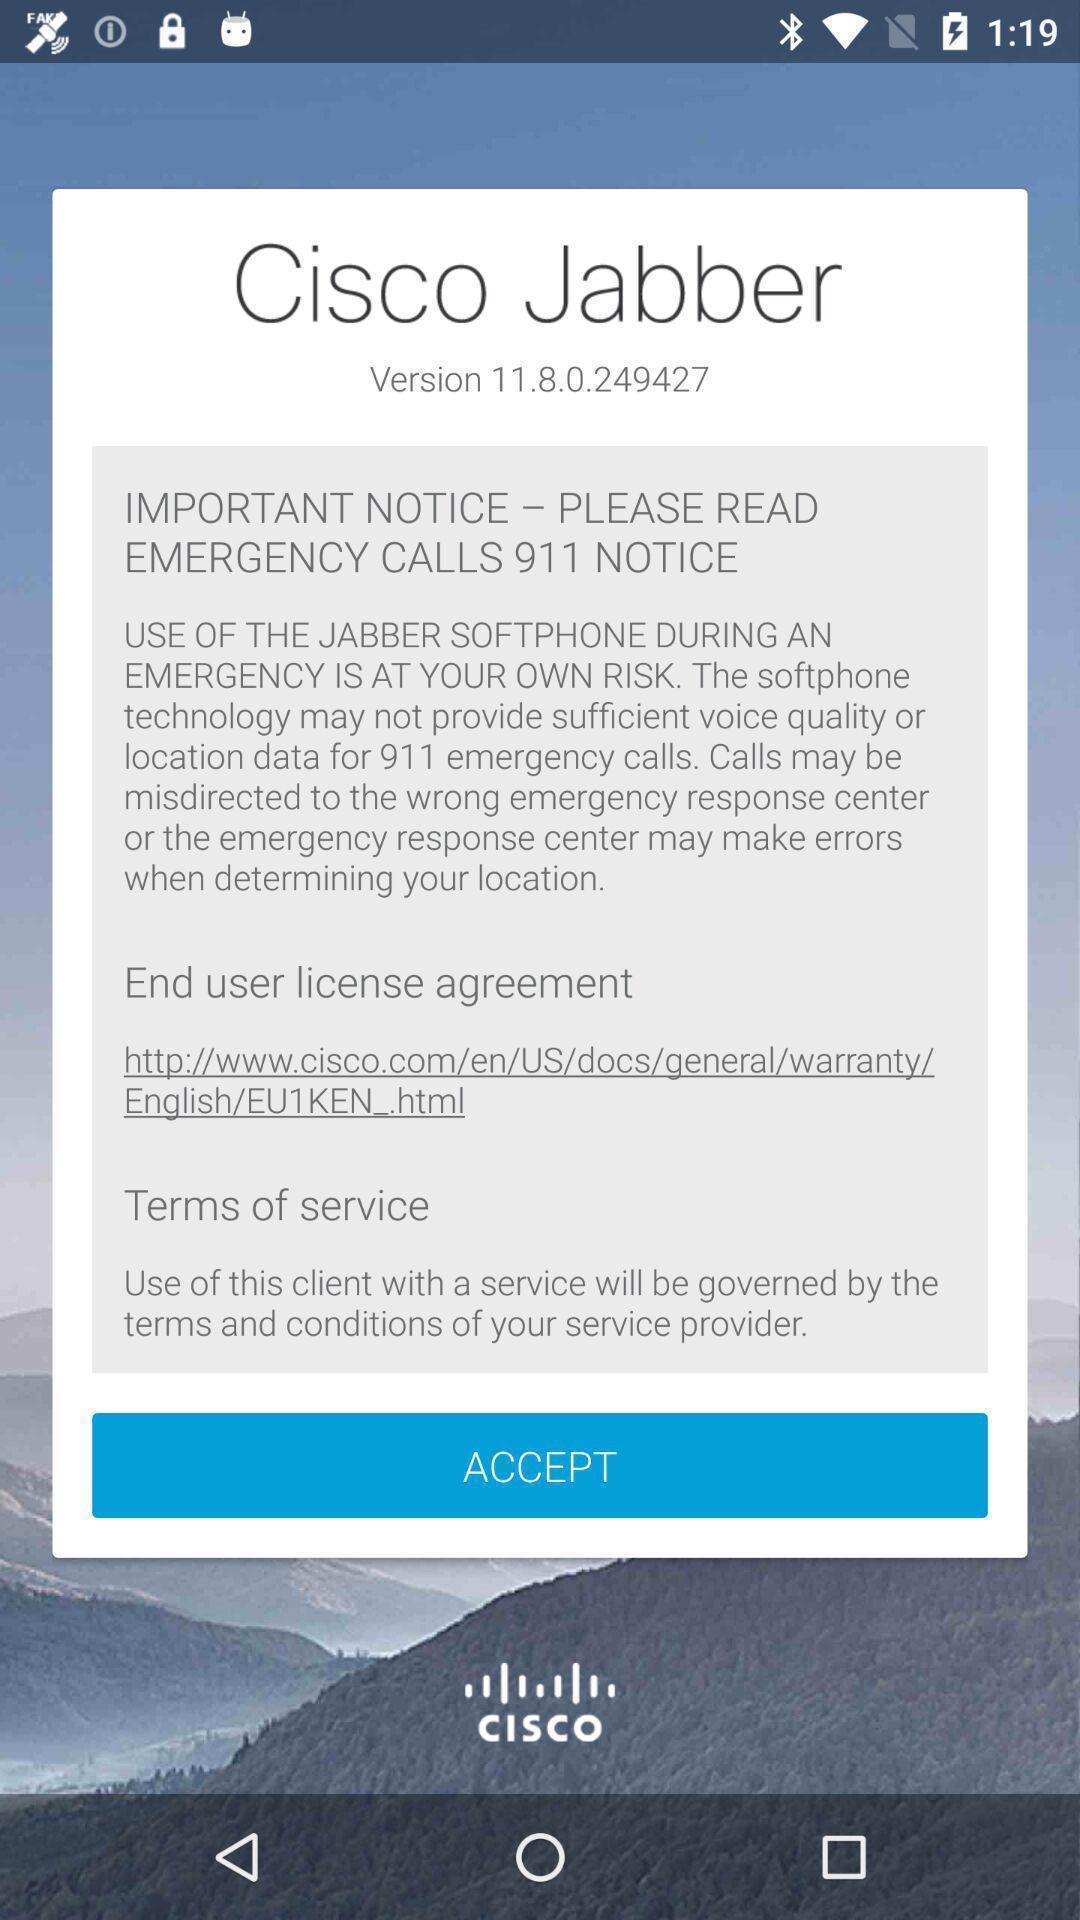Summarize the information in this screenshot. Screen shows to accept terms and conditions. 